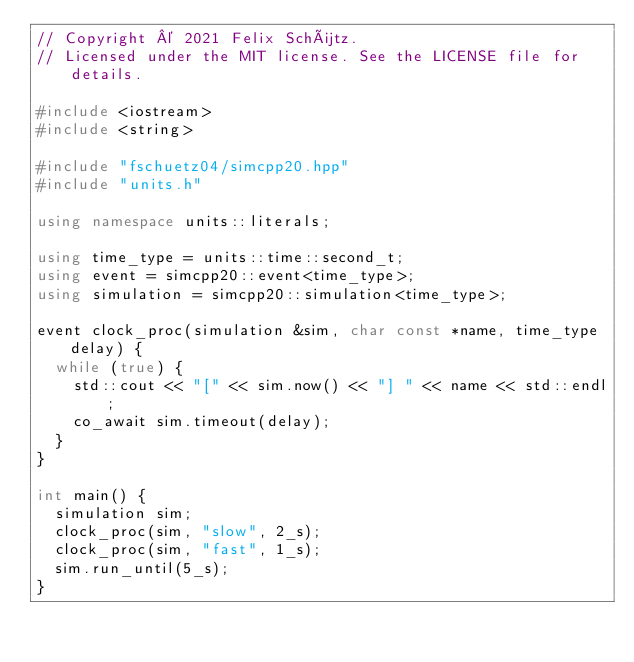<code> <loc_0><loc_0><loc_500><loc_500><_C++_>// Copyright © 2021 Felix Schütz.
// Licensed under the MIT license. See the LICENSE file for details.

#include <iostream>
#include <string>

#include "fschuetz04/simcpp20.hpp"
#include "units.h"

using namespace units::literals;

using time_type = units::time::second_t;
using event = simcpp20::event<time_type>;
using simulation = simcpp20::simulation<time_type>;

event clock_proc(simulation &sim, char const *name, time_type delay) {
  while (true) {
    std::cout << "[" << sim.now() << "] " << name << std::endl;
    co_await sim.timeout(delay);
  }
}

int main() {
  simulation sim;
  clock_proc(sim, "slow", 2_s);
  clock_proc(sim, "fast", 1_s);
  sim.run_until(5_s);
}
</code> 